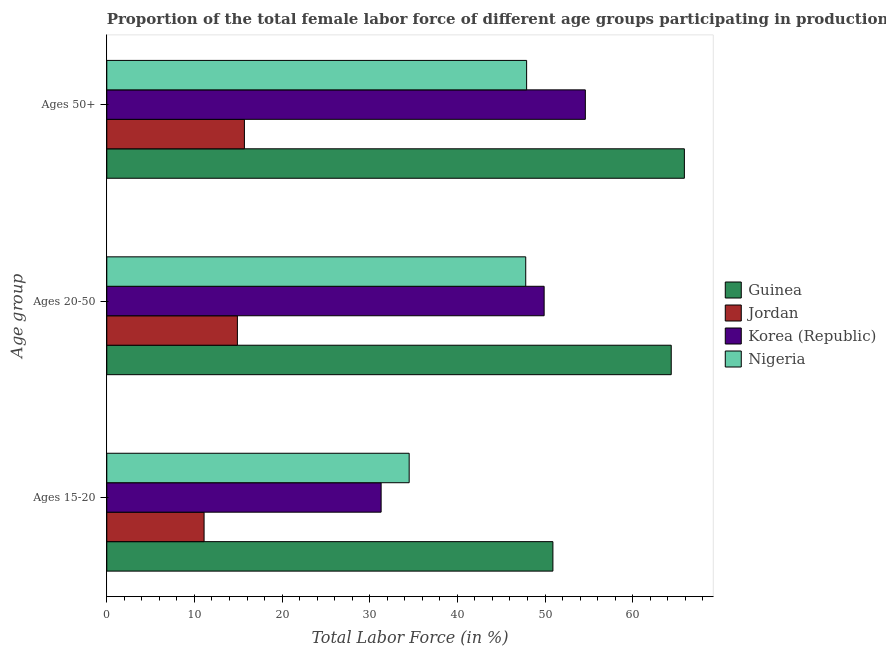How many different coloured bars are there?
Provide a short and direct response. 4. How many groups of bars are there?
Provide a succinct answer. 3. Are the number of bars on each tick of the Y-axis equal?
Make the answer very short. Yes. How many bars are there on the 1st tick from the top?
Offer a terse response. 4. How many bars are there on the 1st tick from the bottom?
Provide a succinct answer. 4. What is the label of the 2nd group of bars from the top?
Provide a short and direct response. Ages 20-50. What is the percentage of female labor force within the age group 15-20 in Nigeria?
Give a very brief answer. 34.5. Across all countries, what is the maximum percentage of female labor force within the age group 15-20?
Provide a succinct answer. 50.9. Across all countries, what is the minimum percentage of female labor force above age 50?
Provide a short and direct response. 15.7. In which country was the percentage of female labor force above age 50 maximum?
Your answer should be very brief. Guinea. In which country was the percentage of female labor force within the age group 15-20 minimum?
Your response must be concise. Jordan. What is the total percentage of female labor force above age 50 in the graph?
Provide a short and direct response. 184.1. What is the difference between the percentage of female labor force within the age group 15-20 in Nigeria and that in Jordan?
Give a very brief answer. 23.4. What is the difference between the percentage of female labor force within the age group 15-20 in Guinea and the percentage of female labor force within the age group 20-50 in Nigeria?
Ensure brevity in your answer.  3.1. What is the average percentage of female labor force within the age group 15-20 per country?
Offer a very short reply. 31.95. What is the difference between the percentage of female labor force above age 50 and percentage of female labor force within the age group 15-20 in Jordan?
Offer a very short reply. 4.6. In how many countries, is the percentage of female labor force within the age group 15-20 greater than 26 %?
Your answer should be compact. 3. What is the ratio of the percentage of female labor force within the age group 20-50 in Jordan to that in Guinea?
Make the answer very short. 0.23. Is the percentage of female labor force within the age group 15-20 in Korea (Republic) less than that in Jordan?
Your response must be concise. No. Is the difference between the percentage of female labor force within the age group 20-50 in Jordan and Guinea greater than the difference between the percentage of female labor force within the age group 15-20 in Jordan and Guinea?
Keep it short and to the point. No. What is the difference between the highest and the second highest percentage of female labor force within the age group 20-50?
Provide a short and direct response. 14.5. What is the difference between the highest and the lowest percentage of female labor force within the age group 15-20?
Ensure brevity in your answer.  39.8. In how many countries, is the percentage of female labor force above age 50 greater than the average percentage of female labor force above age 50 taken over all countries?
Keep it short and to the point. 3. Is the sum of the percentage of female labor force within the age group 15-20 in Guinea and Nigeria greater than the maximum percentage of female labor force within the age group 20-50 across all countries?
Keep it short and to the point. Yes. What does the 3rd bar from the bottom in Ages 15-20 represents?
Offer a terse response. Korea (Republic). Is it the case that in every country, the sum of the percentage of female labor force within the age group 15-20 and percentage of female labor force within the age group 20-50 is greater than the percentage of female labor force above age 50?
Offer a terse response. Yes. What is the difference between two consecutive major ticks on the X-axis?
Offer a very short reply. 10. Are the values on the major ticks of X-axis written in scientific E-notation?
Your answer should be compact. No. Does the graph contain any zero values?
Make the answer very short. No. Does the graph contain grids?
Provide a short and direct response. No. Where does the legend appear in the graph?
Offer a very short reply. Center right. How are the legend labels stacked?
Your response must be concise. Vertical. What is the title of the graph?
Your answer should be compact. Proportion of the total female labor force of different age groups participating in production in 2008. What is the label or title of the X-axis?
Your response must be concise. Total Labor Force (in %). What is the label or title of the Y-axis?
Your response must be concise. Age group. What is the Total Labor Force (in %) in Guinea in Ages 15-20?
Your answer should be very brief. 50.9. What is the Total Labor Force (in %) in Jordan in Ages 15-20?
Make the answer very short. 11.1. What is the Total Labor Force (in %) in Korea (Republic) in Ages 15-20?
Give a very brief answer. 31.3. What is the Total Labor Force (in %) in Nigeria in Ages 15-20?
Give a very brief answer. 34.5. What is the Total Labor Force (in %) of Guinea in Ages 20-50?
Provide a short and direct response. 64.4. What is the Total Labor Force (in %) of Jordan in Ages 20-50?
Make the answer very short. 14.9. What is the Total Labor Force (in %) of Korea (Republic) in Ages 20-50?
Give a very brief answer. 49.9. What is the Total Labor Force (in %) in Nigeria in Ages 20-50?
Provide a short and direct response. 47.8. What is the Total Labor Force (in %) of Guinea in Ages 50+?
Offer a very short reply. 65.9. What is the Total Labor Force (in %) in Jordan in Ages 50+?
Make the answer very short. 15.7. What is the Total Labor Force (in %) in Korea (Republic) in Ages 50+?
Your answer should be compact. 54.6. What is the Total Labor Force (in %) in Nigeria in Ages 50+?
Give a very brief answer. 47.9. Across all Age group, what is the maximum Total Labor Force (in %) in Guinea?
Provide a succinct answer. 65.9. Across all Age group, what is the maximum Total Labor Force (in %) in Jordan?
Your answer should be compact. 15.7. Across all Age group, what is the maximum Total Labor Force (in %) of Korea (Republic)?
Provide a succinct answer. 54.6. Across all Age group, what is the maximum Total Labor Force (in %) in Nigeria?
Your answer should be compact. 47.9. Across all Age group, what is the minimum Total Labor Force (in %) of Guinea?
Offer a terse response. 50.9. Across all Age group, what is the minimum Total Labor Force (in %) in Jordan?
Offer a terse response. 11.1. Across all Age group, what is the minimum Total Labor Force (in %) of Korea (Republic)?
Your answer should be very brief. 31.3. Across all Age group, what is the minimum Total Labor Force (in %) of Nigeria?
Your response must be concise. 34.5. What is the total Total Labor Force (in %) in Guinea in the graph?
Offer a terse response. 181.2. What is the total Total Labor Force (in %) in Jordan in the graph?
Ensure brevity in your answer.  41.7. What is the total Total Labor Force (in %) of Korea (Republic) in the graph?
Provide a succinct answer. 135.8. What is the total Total Labor Force (in %) of Nigeria in the graph?
Offer a very short reply. 130.2. What is the difference between the Total Labor Force (in %) of Jordan in Ages 15-20 and that in Ages 20-50?
Make the answer very short. -3.8. What is the difference between the Total Labor Force (in %) in Korea (Republic) in Ages 15-20 and that in Ages 20-50?
Provide a short and direct response. -18.6. What is the difference between the Total Labor Force (in %) in Nigeria in Ages 15-20 and that in Ages 20-50?
Make the answer very short. -13.3. What is the difference between the Total Labor Force (in %) of Guinea in Ages 15-20 and that in Ages 50+?
Provide a succinct answer. -15. What is the difference between the Total Labor Force (in %) of Jordan in Ages 15-20 and that in Ages 50+?
Provide a short and direct response. -4.6. What is the difference between the Total Labor Force (in %) in Korea (Republic) in Ages 15-20 and that in Ages 50+?
Keep it short and to the point. -23.3. What is the difference between the Total Labor Force (in %) of Jordan in Ages 20-50 and that in Ages 50+?
Make the answer very short. -0.8. What is the difference between the Total Labor Force (in %) in Korea (Republic) in Ages 20-50 and that in Ages 50+?
Make the answer very short. -4.7. What is the difference between the Total Labor Force (in %) of Guinea in Ages 15-20 and the Total Labor Force (in %) of Jordan in Ages 20-50?
Provide a short and direct response. 36. What is the difference between the Total Labor Force (in %) in Guinea in Ages 15-20 and the Total Labor Force (in %) in Nigeria in Ages 20-50?
Make the answer very short. 3.1. What is the difference between the Total Labor Force (in %) of Jordan in Ages 15-20 and the Total Labor Force (in %) of Korea (Republic) in Ages 20-50?
Make the answer very short. -38.8. What is the difference between the Total Labor Force (in %) in Jordan in Ages 15-20 and the Total Labor Force (in %) in Nigeria in Ages 20-50?
Offer a very short reply. -36.7. What is the difference between the Total Labor Force (in %) of Korea (Republic) in Ages 15-20 and the Total Labor Force (in %) of Nigeria in Ages 20-50?
Give a very brief answer. -16.5. What is the difference between the Total Labor Force (in %) in Guinea in Ages 15-20 and the Total Labor Force (in %) in Jordan in Ages 50+?
Your answer should be compact. 35.2. What is the difference between the Total Labor Force (in %) in Jordan in Ages 15-20 and the Total Labor Force (in %) in Korea (Republic) in Ages 50+?
Your answer should be very brief. -43.5. What is the difference between the Total Labor Force (in %) of Jordan in Ages 15-20 and the Total Labor Force (in %) of Nigeria in Ages 50+?
Your answer should be compact. -36.8. What is the difference between the Total Labor Force (in %) of Korea (Republic) in Ages 15-20 and the Total Labor Force (in %) of Nigeria in Ages 50+?
Provide a succinct answer. -16.6. What is the difference between the Total Labor Force (in %) in Guinea in Ages 20-50 and the Total Labor Force (in %) in Jordan in Ages 50+?
Offer a very short reply. 48.7. What is the difference between the Total Labor Force (in %) of Jordan in Ages 20-50 and the Total Labor Force (in %) of Korea (Republic) in Ages 50+?
Ensure brevity in your answer.  -39.7. What is the difference between the Total Labor Force (in %) in Jordan in Ages 20-50 and the Total Labor Force (in %) in Nigeria in Ages 50+?
Provide a short and direct response. -33. What is the difference between the Total Labor Force (in %) in Korea (Republic) in Ages 20-50 and the Total Labor Force (in %) in Nigeria in Ages 50+?
Provide a short and direct response. 2. What is the average Total Labor Force (in %) in Guinea per Age group?
Offer a very short reply. 60.4. What is the average Total Labor Force (in %) in Jordan per Age group?
Your answer should be very brief. 13.9. What is the average Total Labor Force (in %) in Korea (Republic) per Age group?
Ensure brevity in your answer.  45.27. What is the average Total Labor Force (in %) in Nigeria per Age group?
Offer a terse response. 43.4. What is the difference between the Total Labor Force (in %) of Guinea and Total Labor Force (in %) of Jordan in Ages 15-20?
Ensure brevity in your answer.  39.8. What is the difference between the Total Labor Force (in %) of Guinea and Total Labor Force (in %) of Korea (Republic) in Ages 15-20?
Provide a succinct answer. 19.6. What is the difference between the Total Labor Force (in %) in Jordan and Total Labor Force (in %) in Korea (Republic) in Ages 15-20?
Offer a very short reply. -20.2. What is the difference between the Total Labor Force (in %) of Jordan and Total Labor Force (in %) of Nigeria in Ages 15-20?
Your response must be concise. -23.4. What is the difference between the Total Labor Force (in %) of Korea (Republic) and Total Labor Force (in %) of Nigeria in Ages 15-20?
Your response must be concise. -3.2. What is the difference between the Total Labor Force (in %) of Guinea and Total Labor Force (in %) of Jordan in Ages 20-50?
Your answer should be compact. 49.5. What is the difference between the Total Labor Force (in %) in Guinea and Total Labor Force (in %) in Korea (Republic) in Ages 20-50?
Offer a terse response. 14.5. What is the difference between the Total Labor Force (in %) in Jordan and Total Labor Force (in %) in Korea (Republic) in Ages 20-50?
Provide a succinct answer. -35. What is the difference between the Total Labor Force (in %) in Jordan and Total Labor Force (in %) in Nigeria in Ages 20-50?
Ensure brevity in your answer.  -32.9. What is the difference between the Total Labor Force (in %) of Korea (Republic) and Total Labor Force (in %) of Nigeria in Ages 20-50?
Provide a short and direct response. 2.1. What is the difference between the Total Labor Force (in %) of Guinea and Total Labor Force (in %) of Jordan in Ages 50+?
Provide a short and direct response. 50.2. What is the difference between the Total Labor Force (in %) of Jordan and Total Labor Force (in %) of Korea (Republic) in Ages 50+?
Offer a very short reply. -38.9. What is the difference between the Total Labor Force (in %) in Jordan and Total Labor Force (in %) in Nigeria in Ages 50+?
Your response must be concise. -32.2. What is the ratio of the Total Labor Force (in %) in Guinea in Ages 15-20 to that in Ages 20-50?
Your answer should be very brief. 0.79. What is the ratio of the Total Labor Force (in %) of Jordan in Ages 15-20 to that in Ages 20-50?
Provide a succinct answer. 0.74. What is the ratio of the Total Labor Force (in %) of Korea (Republic) in Ages 15-20 to that in Ages 20-50?
Offer a very short reply. 0.63. What is the ratio of the Total Labor Force (in %) of Nigeria in Ages 15-20 to that in Ages 20-50?
Your response must be concise. 0.72. What is the ratio of the Total Labor Force (in %) of Guinea in Ages 15-20 to that in Ages 50+?
Your answer should be compact. 0.77. What is the ratio of the Total Labor Force (in %) of Jordan in Ages 15-20 to that in Ages 50+?
Keep it short and to the point. 0.71. What is the ratio of the Total Labor Force (in %) in Korea (Republic) in Ages 15-20 to that in Ages 50+?
Provide a succinct answer. 0.57. What is the ratio of the Total Labor Force (in %) in Nigeria in Ages 15-20 to that in Ages 50+?
Your answer should be very brief. 0.72. What is the ratio of the Total Labor Force (in %) of Guinea in Ages 20-50 to that in Ages 50+?
Provide a succinct answer. 0.98. What is the ratio of the Total Labor Force (in %) in Jordan in Ages 20-50 to that in Ages 50+?
Offer a terse response. 0.95. What is the ratio of the Total Labor Force (in %) in Korea (Republic) in Ages 20-50 to that in Ages 50+?
Your response must be concise. 0.91. What is the ratio of the Total Labor Force (in %) of Nigeria in Ages 20-50 to that in Ages 50+?
Your answer should be very brief. 1. What is the difference between the highest and the second highest Total Labor Force (in %) in Guinea?
Keep it short and to the point. 1.5. What is the difference between the highest and the second highest Total Labor Force (in %) in Nigeria?
Ensure brevity in your answer.  0.1. What is the difference between the highest and the lowest Total Labor Force (in %) in Guinea?
Your answer should be compact. 15. What is the difference between the highest and the lowest Total Labor Force (in %) in Jordan?
Keep it short and to the point. 4.6. What is the difference between the highest and the lowest Total Labor Force (in %) in Korea (Republic)?
Keep it short and to the point. 23.3. What is the difference between the highest and the lowest Total Labor Force (in %) in Nigeria?
Give a very brief answer. 13.4. 